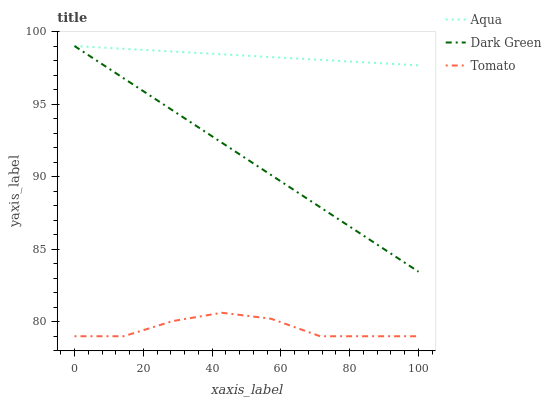Does Tomato have the minimum area under the curve?
Answer yes or no. Yes. Does Aqua have the maximum area under the curve?
Answer yes or no. Yes. Does Dark Green have the minimum area under the curve?
Answer yes or no. No. Does Dark Green have the maximum area under the curve?
Answer yes or no. No. Is Aqua the smoothest?
Answer yes or no. Yes. Is Tomato the roughest?
Answer yes or no. Yes. Is Dark Green the smoothest?
Answer yes or no. No. Is Dark Green the roughest?
Answer yes or no. No. Does Tomato have the lowest value?
Answer yes or no. Yes. Does Dark Green have the lowest value?
Answer yes or no. No. Does Dark Green have the highest value?
Answer yes or no. Yes. Is Tomato less than Aqua?
Answer yes or no. Yes. Is Dark Green greater than Tomato?
Answer yes or no. Yes. Does Dark Green intersect Aqua?
Answer yes or no. Yes. Is Dark Green less than Aqua?
Answer yes or no. No. Is Dark Green greater than Aqua?
Answer yes or no. No. Does Tomato intersect Aqua?
Answer yes or no. No. 